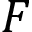Convert formula to latex. <formula><loc_0><loc_0><loc_500><loc_500>F</formula> 